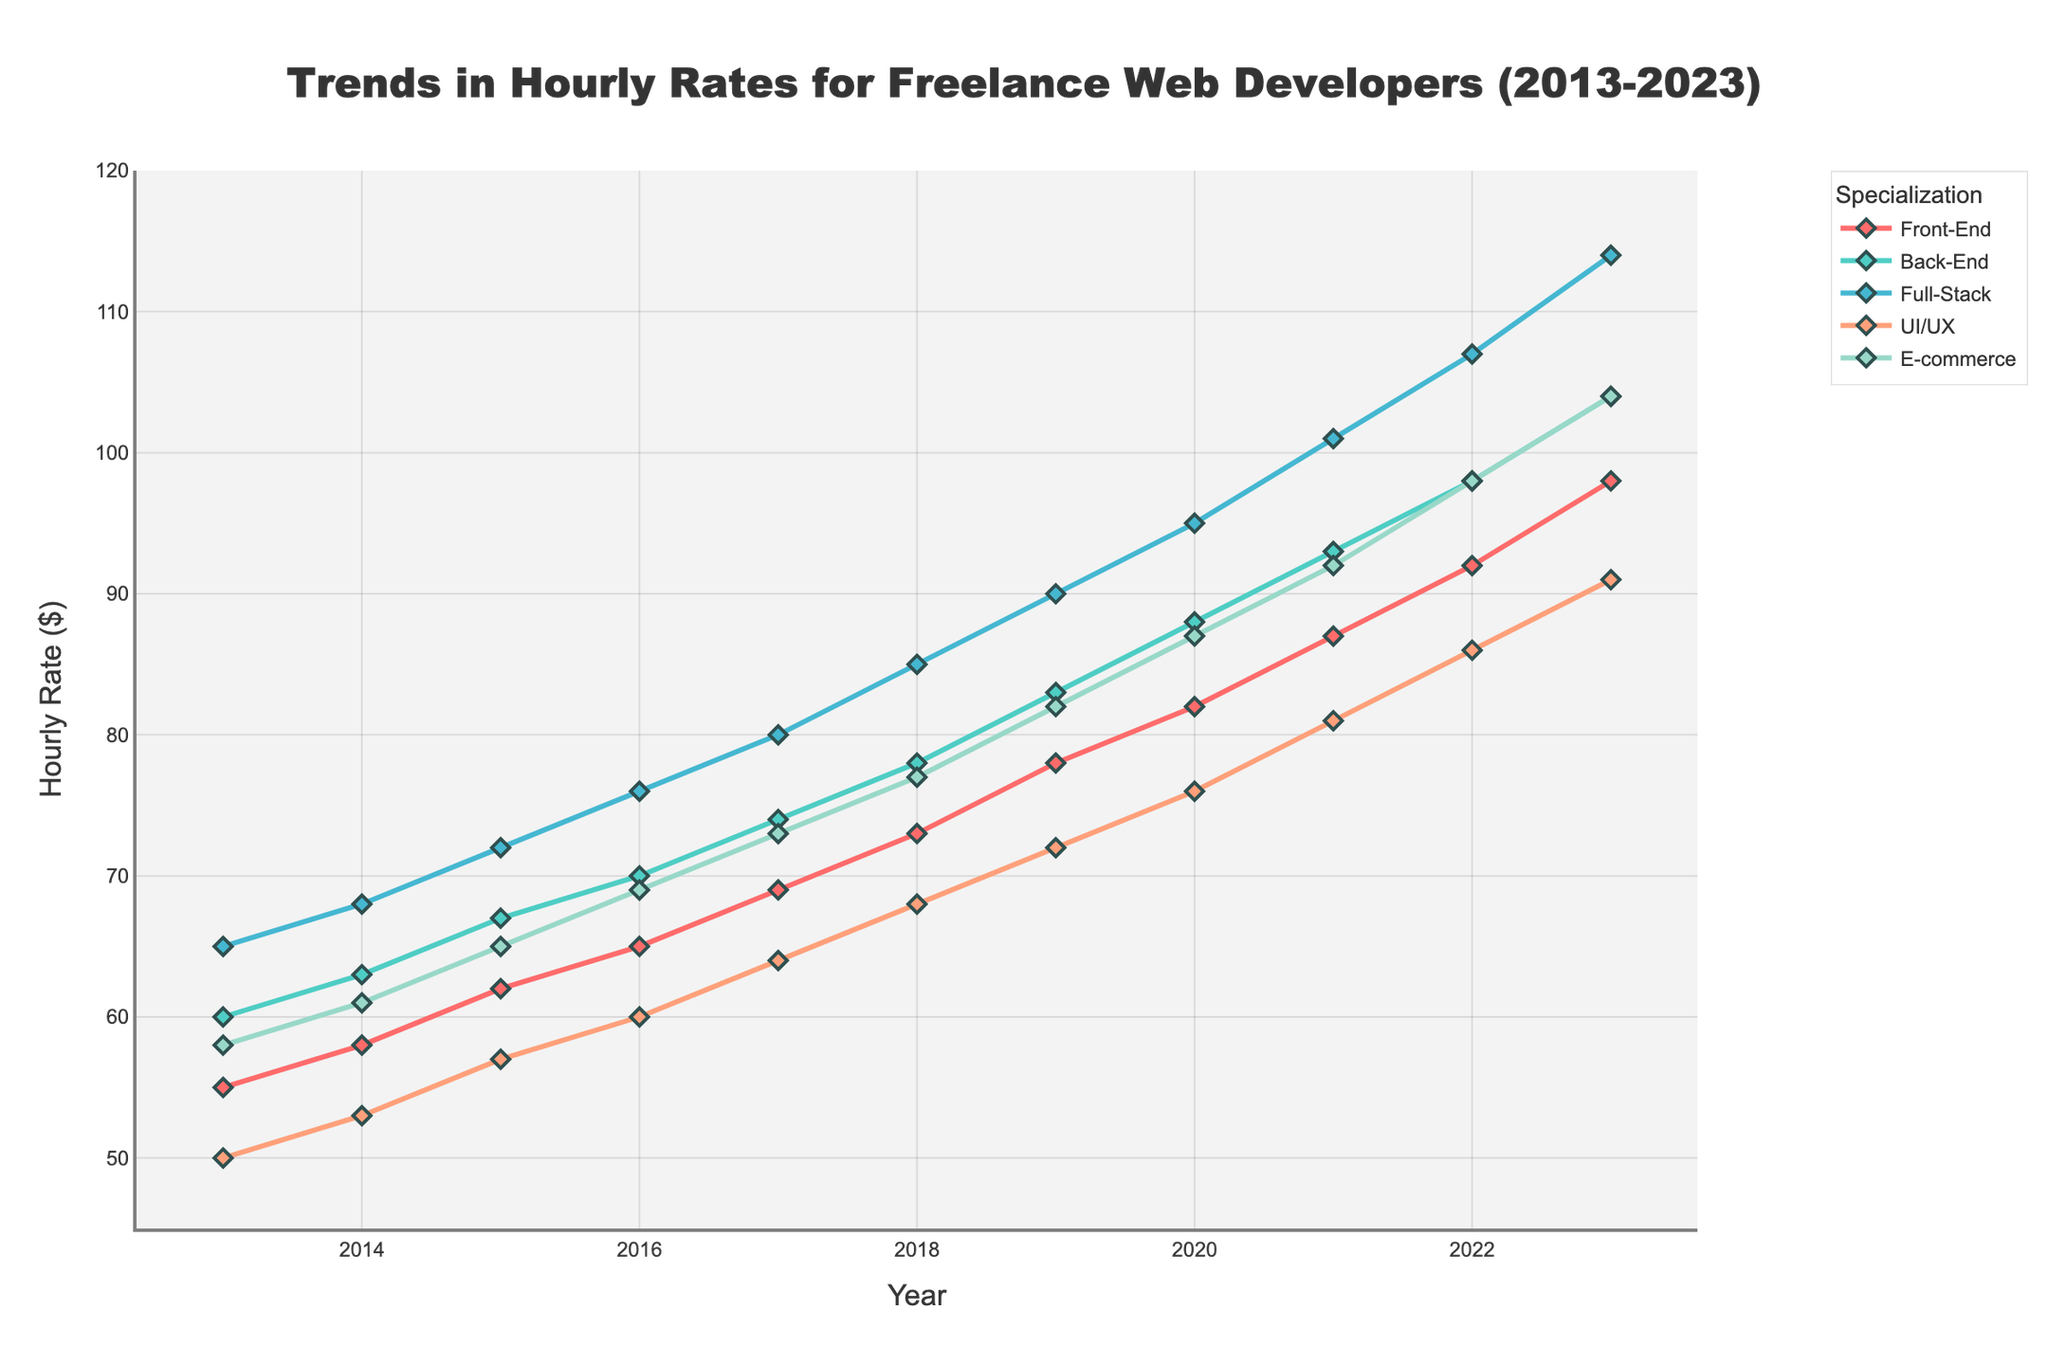What's the overall trend in hourly rates for Full-Stack developers from 2013 to 2023? The hourly rates for Full-Stack developers consistently increased each year from $65 in 2013 to $114 in 2023, indicating a steady upward trend.
Answer: Steady upward trend What year did the UI/UX developers' hourly rate reach $81? By examining the UI/UX developers' hourly rate across the years, we can see that it reached $81 in 2021.
Answer: 2021 Which specialization had the highest hourly rate in 2023? Comparing the hourly rates in 2023, Full-Stack developers had the highest rate at $114, which is higher than any other specialization.
Answer: Full-Stack How much did the hourly rate for E-commerce developers increase from 2015 to 2020? Subtract the hourly rate in 2015 ($65) from the rate in 2020 ($87). The increase is $87 - $65 = $22.
Answer: $22 Compare the hourly rate trends for Front-End and Back-End developers. Which one had a higher rate more often? By comparing their rates year by year, Back-End developers consistently had a higher rate than Front-End developers every single year from 2013 to 2023.
Answer: Back-End developers What is the average hourly rate for UI/UX developers over the decade? The sum of UI/UX rates from 2013 to 2023 is (50 + 53 + 57 + 60 + 64 + 68 + 72 + 76 + 81 + 86 + 91) = 758. Divide this by 11 (the number of years) to get the average: 758 / 11 ≈ 68.91.
Answer: ≈ $68.91 Did the hourly rate for Front-End developers ever exceed the rate for Full-Stack developers in any given year? By comparing their hourly rates for each year, Front-End developers never had a higher rate than Full-Stack developers from 2013 to 2023.
Answer: No What is the rate difference between the highest and lowest-paying specializations in 2019? In 2019, the highest-paid were Full-Stack developers at $90 and the lowest-paid were Front-End developers at $78. The difference is $90 - $78 = $12.
Answer: $12 